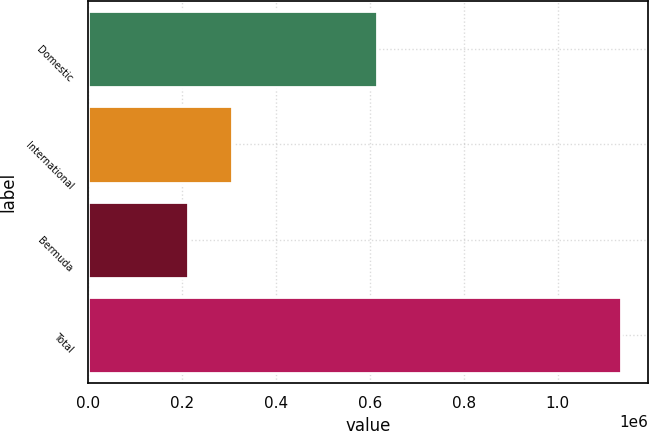<chart> <loc_0><loc_0><loc_500><loc_500><bar_chart><fcel>Domestic<fcel>International<fcel>Bermuda<fcel>Total<nl><fcel>616068<fcel>306229<fcel>213289<fcel>1.13559e+06<nl></chart> 